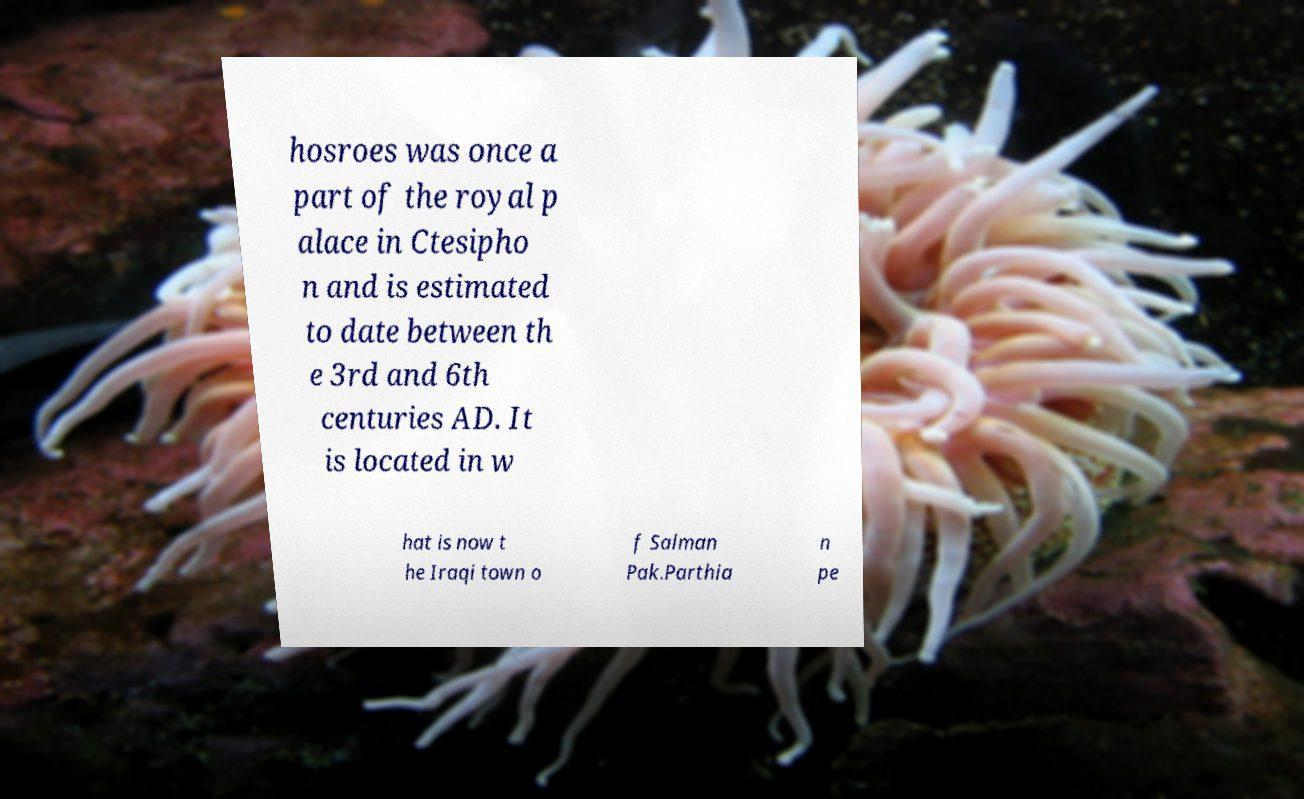Please read and relay the text visible in this image. What does it say? hosroes was once a part of the royal p alace in Ctesipho n and is estimated to date between th e 3rd and 6th centuries AD. It is located in w hat is now t he Iraqi town o f Salman Pak.Parthia n pe 